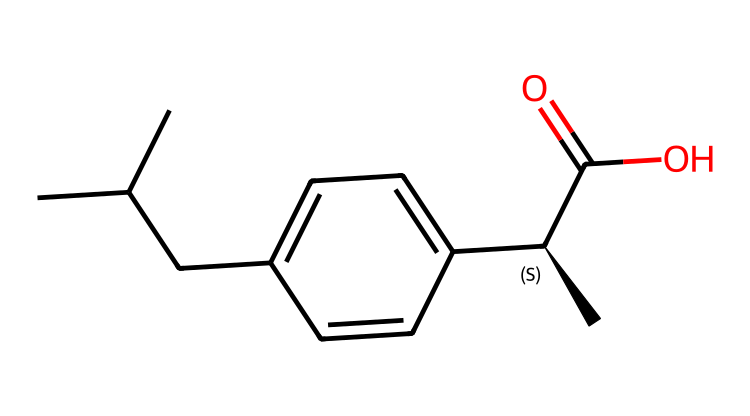What is the molecular formula of ibuprofen? The molecular formula can be determined by counting the carbon, hydrogen, and oxygen atoms in the SMILES representation. There are 13 carbons, 18 hydrogens, and 2 oxygens, resulting in the formula C13H18O2.
Answer: C13H18O2 How many chiral centers does this molecule have? By inspecting the SMILES representation, we identify a chiral center at the carbon marked with [C@H]. This indicates there is one chiral center in the molecule.
Answer: 1 What type of functional group is present in ibuprofen? The molecular structure contains a carboxylic acid group (-COOH) as seen in "C(=O)O" part of the SMILES. This indicates the presence of a functional group characteristic of acids.
Answer: carboxylic acid What is the total number of carbon atoms in ibuprofen? The number of carbon atoms can be counted directly from the SMILES notation. There are 13 carbon atoms visible in the structure derived from the notation.
Answer: 13 Why is ibuprofen classified as a chiral compound? A compound is classified as chiral when it has at least one chiral center, which gives rise to non-superimposable mirror images. In this case, the specific configuration at the chiral carbon leads to two enantiomers.
Answer: one chiral center What is the significance of the [C@H] notation in the SMILES? The [C@H] notation specifically indicates the presence of a chiral carbon atom that has a specific stereochemistry, which distinguishes one enantiomer from another in the compound.
Answer: chiral center Which part of the molecule is responsible for its anti-inflammatory properties? The presence of the carboxylic acid group (C(=O)O) is critical because similar functional groups in non-steroidal anti-inflammatory drugs (NSAIDs) are typically involved in their mechanism of action.
Answer: carboxylic acid 